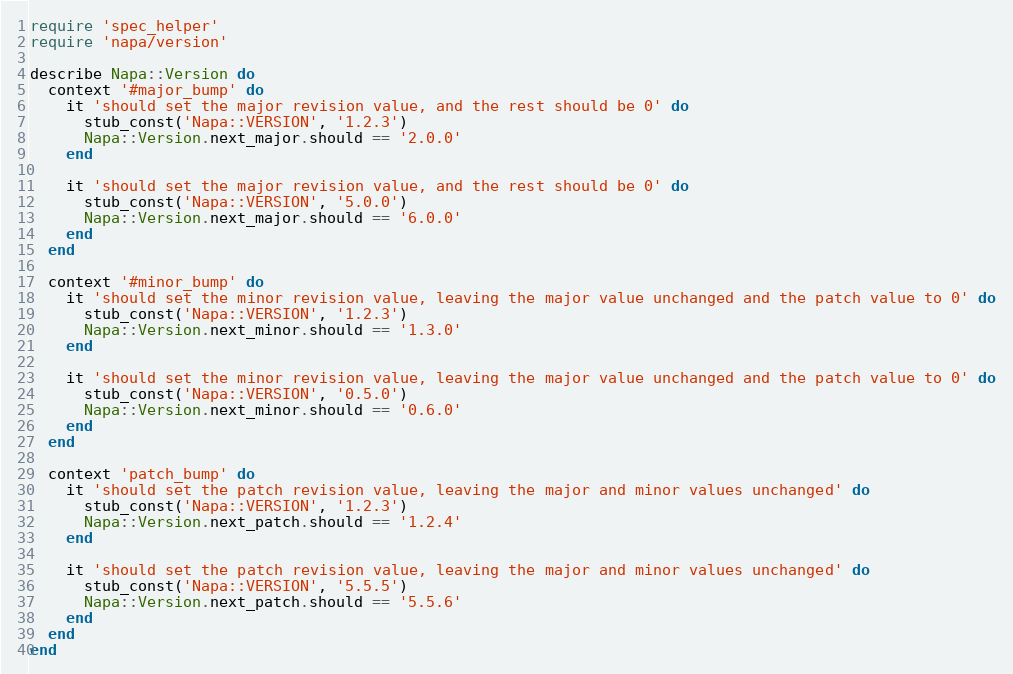Convert code to text. <code><loc_0><loc_0><loc_500><loc_500><_Ruby_>require 'spec_helper'
require 'napa/version'

describe Napa::Version do
  context '#major_bump' do
    it 'should set the major revision value, and the rest should be 0' do
      stub_const('Napa::VERSION', '1.2.3')
      Napa::Version.next_major.should == '2.0.0'
    end

    it 'should set the major revision value, and the rest should be 0' do
      stub_const('Napa::VERSION', '5.0.0')
      Napa::Version.next_major.should == '6.0.0'
    end
  end

  context '#minor_bump' do
    it 'should set the minor revision value, leaving the major value unchanged and the patch value to 0' do
      stub_const('Napa::VERSION', '1.2.3')
      Napa::Version.next_minor.should == '1.3.0'
    end

    it 'should set the minor revision value, leaving the major value unchanged and the patch value to 0' do
      stub_const('Napa::VERSION', '0.5.0')
      Napa::Version.next_minor.should == '0.6.0'
    end
  end

  context 'patch_bump' do
    it 'should set the patch revision value, leaving the major and minor values unchanged' do
      stub_const('Napa::VERSION', '1.2.3')
      Napa::Version.next_patch.should == '1.2.4'
    end

    it 'should set the patch revision value, leaving the major and minor values unchanged' do
      stub_const('Napa::VERSION', '5.5.5')
      Napa::Version.next_patch.should == '5.5.6'
    end
  end
end
</code> 